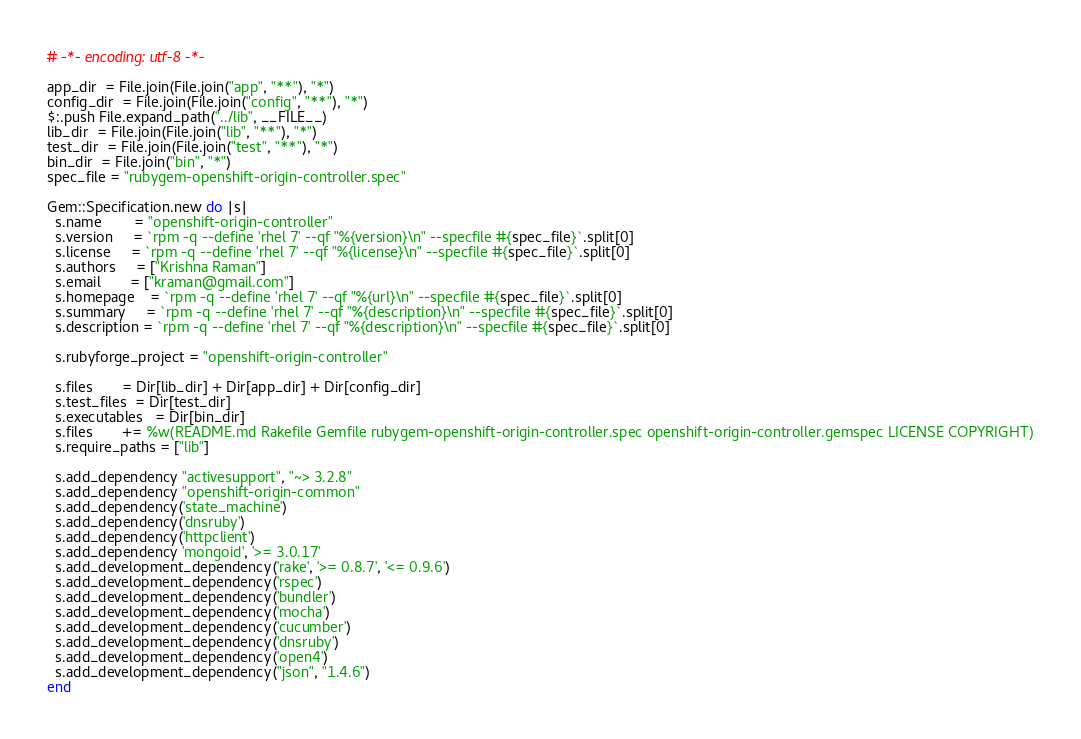<code> <loc_0><loc_0><loc_500><loc_500><_Ruby_># -*- encoding: utf-8 -*-

app_dir  = File.join(File.join("app", "**"), "*")
config_dir  = File.join(File.join("config", "**"), "*")
$:.push File.expand_path("../lib", __FILE__)
lib_dir  = File.join(File.join("lib", "**"), "*")
test_dir  = File.join(File.join("test", "**"), "*")
bin_dir  = File.join("bin", "*")
spec_file = "rubygem-openshift-origin-controller.spec"

Gem::Specification.new do |s|
  s.name        = "openshift-origin-controller"
  s.version     = `rpm -q --define 'rhel 7' --qf "%{version}\n" --specfile #{spec_file}`.split[0]
  s.license     = `rpm -q --define 'rhel 7' --qf "%{license}\n" --specfile #{spec_file}`.split[0]
  s.authors     = ["Krishna Raman"]
  s.email       = ["kraman@gmail.com"]
  s.homepage    = `rpm -q --define 'rhel 7' --qf "%{url}\n" --specfile #{spec_file}`.split[0]
  s.summary     = `rpm -q --define 'rhel 7' --qf "%{description}\n" --specfile #{spec_file}`.split[0]
  s.description = `rpm -q --define 'rhel 7' --qf "%{description}\n" --specfile #{spec_file}`.split[0]

  s.rubyforge_project = "openshift-origin-controller"

  s.files       = Dir[lib_dir] + Dir[app_dir] + Dir[config_dir]
  s.test_files  = Dir[test_dir]
  s.executables   = Dir[bin_dir]
  s.files       += %w(README.md Rakefile Gemfile rubygem-openshift-origin-controller.spec openshift-origin-controller.gemspec LICENSE COPYRIGHT)
  s.require_paths = ["lib"]

  s.add_dependency "activesupport", "~> 3.2.8"
  s.add_dependency "openshift-origin-common"
  s.add_dependency('state_machine')
  s.add_dependency('dnsruby')
  s.add_dependency('httpclient')
  s.add_dependency 'mongoid', '>= 3.0.17'
  s.add_development_dependency('rake', '>= 0.8.7', '<= 0.9.6')  
  s.add_development_dependency('rspec')
  s.add_development_dependency('bundler')
  s.add_development_dependency('mocha')
  s.add_development_dependency('cucumber')
  s.add_development_dependency('dnsruby')
  s.add_development_dependency('open4')
  s.add_development_dependency("json", "1.4.6")
end
</code> 